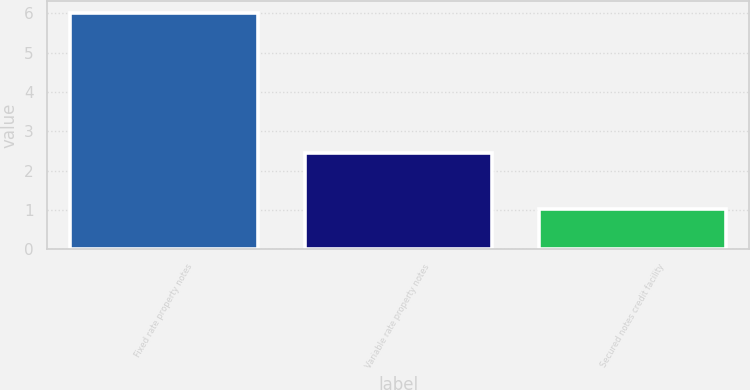<chart> <loc_0><loc_0><loc_500><loc_500><bar_chart><fcel>Fixed rate property notes<fcel>Variable rate property notes<fcel>Secured notes credit facility<nl><fcel>6.01<fcel>2.46<fcel>1.02<nl></chart> 